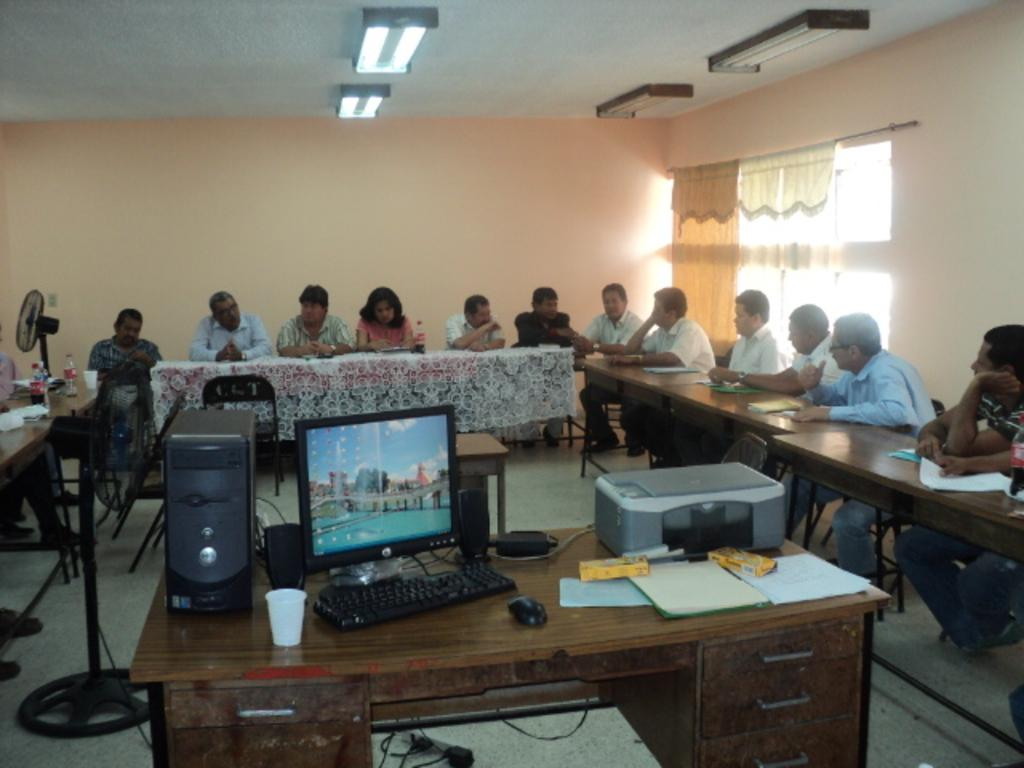How many people are in the image? There is a group of people in the image. What are the people doing in the image? The people are sitting on chairs. Where are the chairs located in relation to the table? The chairs are in front of a table. What electronic devices are on the table? There is a monitor, a keyboard, and a CPU on the table. Are there any other objects on the table besides the electronic devices? Yes, there are other objects on the table. What type of shoe is being used as a paperweight on the table? There is no shoe present on the table in the image. What sense is being stimulated by the objects on the table? The image does not provide information about senses being stimulated by the objects on the table. 